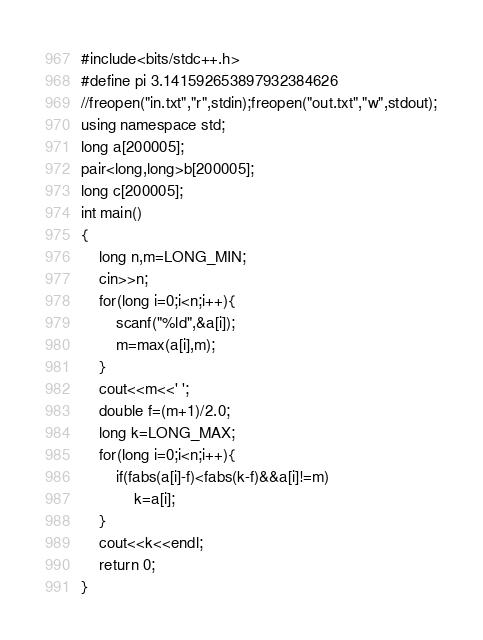Convert code to text. <code><loc_0><loc_0><loc_500><loc_500><_C++_>#include<bits/stdc++.h>
#define pi 3.141592653897932384626
//freopen("in.txt","r",stdin);freopen("out.txt","w",stdout);
using namespace std;
long a[200005];
pair<long,long>b[200005];
long c[200005];
int main()
{
    long n,m=LONG_MIN;
    cin>>n;
    for(long i=0;i<n;i++){
        scanf("%ld",&a[i]);
        m=max(a[i],m);
    }
    cout<<m<<' ';
    double f=(m+1)/2.0;
    long k=LONG_MAX;
    for(long i=0;i<n;i++){
        if(fabs(a[i]-f)<fabs(k-f)&&a[i]!=m)
            k=a[i];
    }
    cout<<k<<endl;
	return 0;
}
</code> 